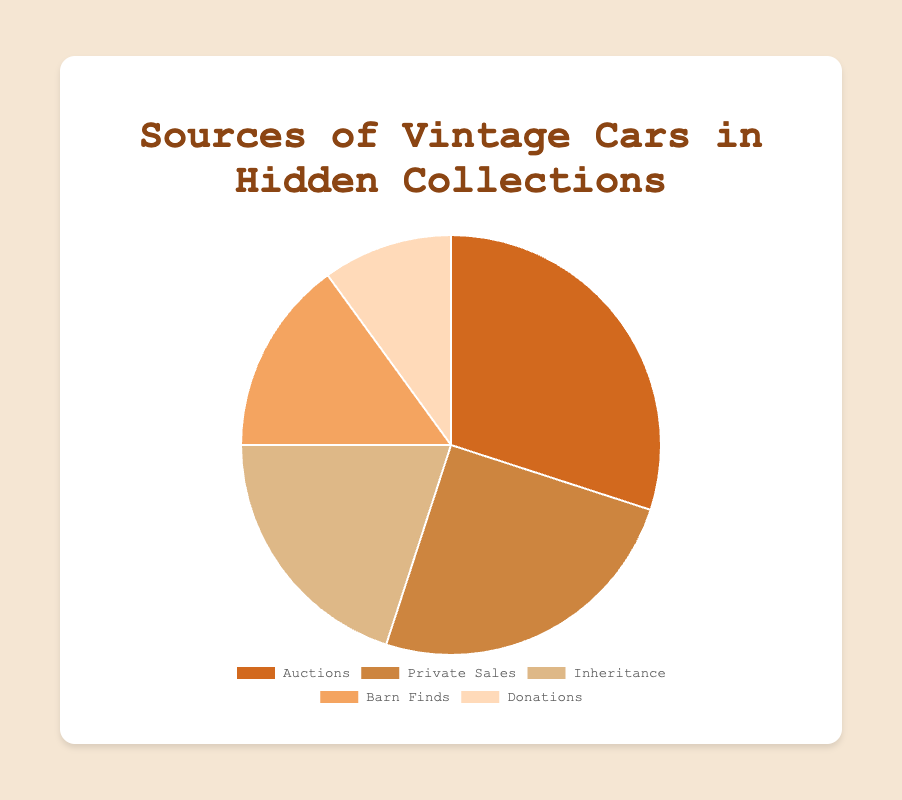What's the most common source of vintage cars? The slice representing "Auctions" is the largest in the pie chart with 30%. This indicates that most vintage cars come from auctions.
Answer: Auctions Which source contributes the least to vintage car collections? The slice representing "Donations" is the smallest in the pie chart with 10%. This indicates that donations contribute the least.
Answer: Donations How much more common are private sales compared to donations? Private sales have 25%, and donations have 10%. The difference is 25% - 10% = 15%.
Answer: 15% What is the combined percentage of cars obtained through inheritance and barn finds? Inheritance is 20% and barn finds are 15%. The combined percentage is 20% + 15% = 35%.
Answer: 35% Which two sources combined make up the same proportion as the auctioned cars? Auctions make up 30%. Both private sales (25%) and donations (10%) combined make 35%, and inheritance (20%) and barn finds (15%) combined make 35%. Only inheritance (20%) and barn finds (15%) equal 35%, the others exceed 30%.
Answer: Inheritance and Barn Finds What percentage of the vintage cars comes from sources other than auctions? The data shows that auctions make up 30%, so the remaining sources contribute 100% - 30% = 70%.
Answer: 70% Is the percentage of vintage cars from private sales more or less than that from inheritance and donations combined? Inheritance is 20%, and donations are 10%, for a combined total of 30%. Private sales are 25%. Comparing 25% to 30%, private sales are less.
Answer: Less Which source has a light tan color in the chart? The light tan color corresponds to "Donations" with 10%, which is the smallest slice in the chart.
Answer: Donations 